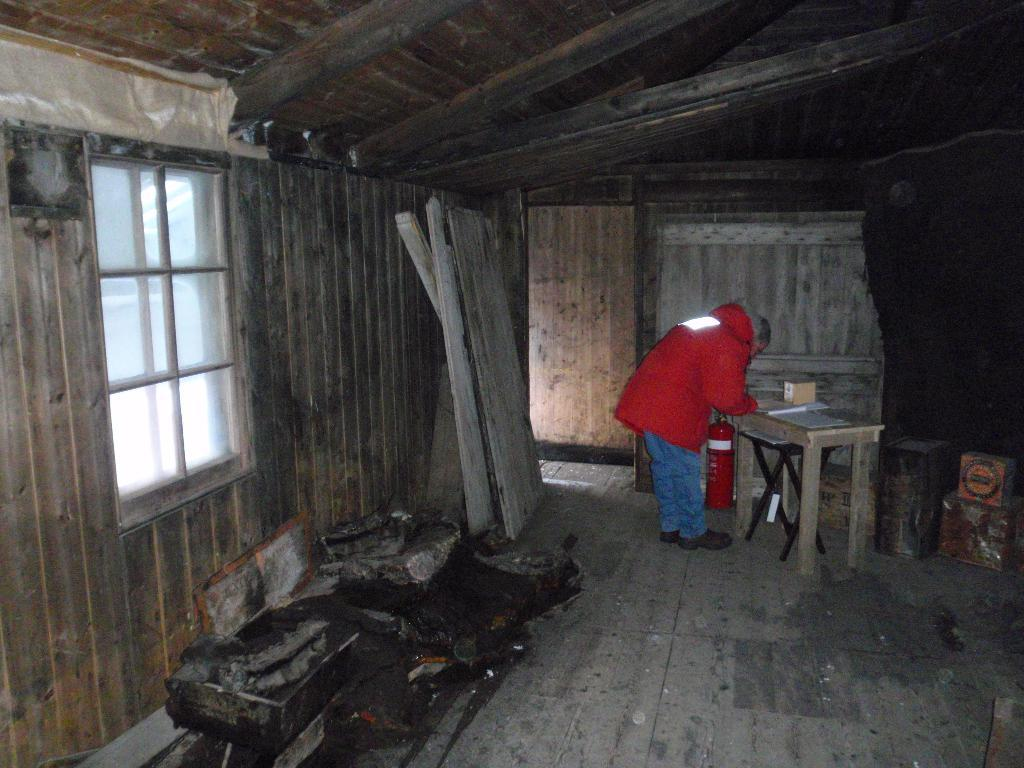What type of structure is visible in the image? There is a house in the image. What feature of the house can be seen in the image? There is a window in the image. Who is present in the image? There is a man standing in the image. What piece of furniture is in the image? There is a table in the image. What object is on the table in the image? There is a box on the table in the image. What type of credit card is the man holding in the image? There is no credit card visible in the image; the man is not holding anything. What color is the bag on the man's knee in the image? There is no bag or knee visible in the image; the man is standing upright. 